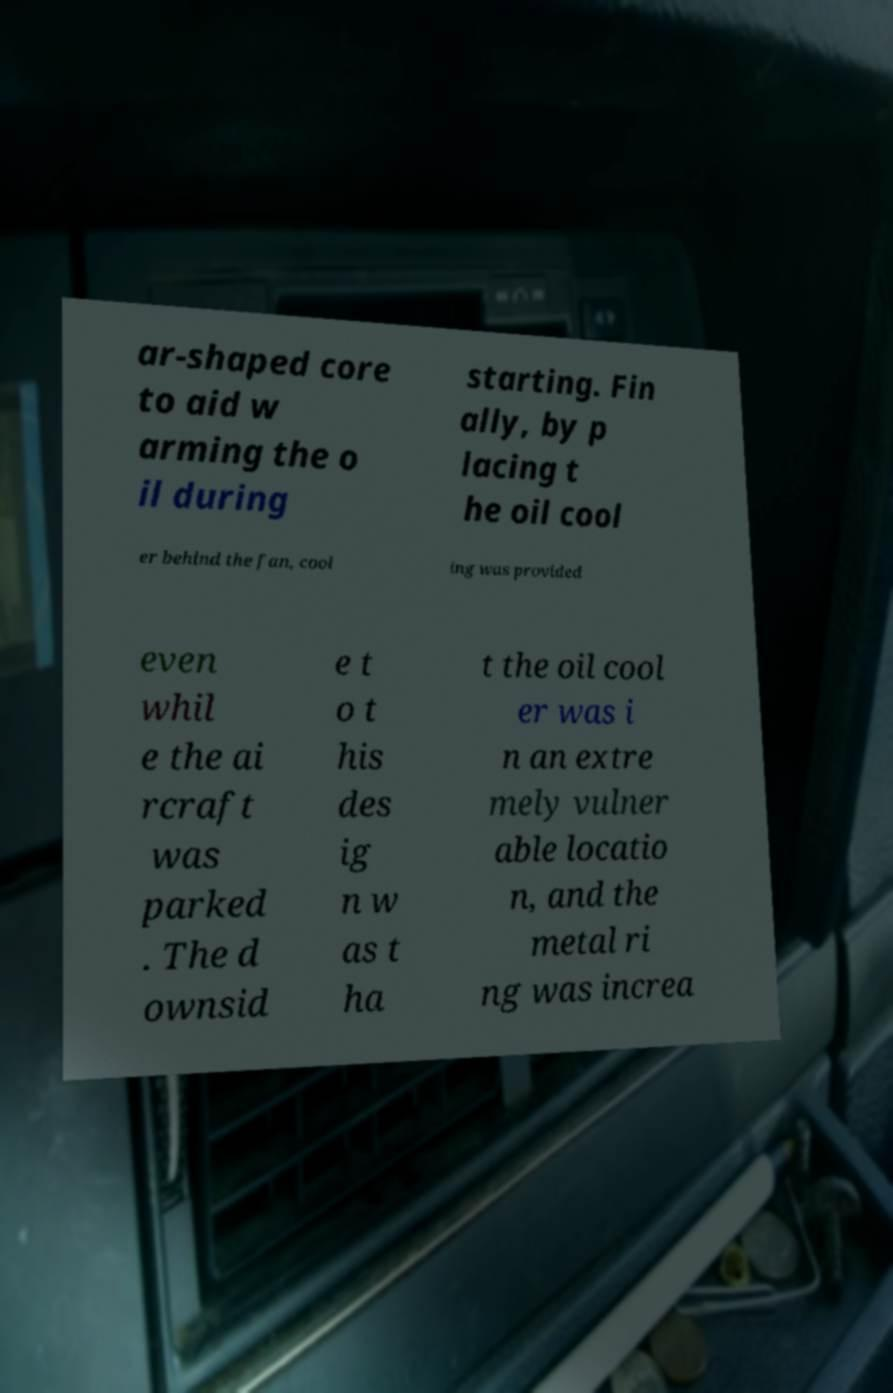I need the written content from this picture converted into text. Can you do that? ar-shaped core to aid w arming the o il during starting. Fin ally, by p lacing t he oil cool er behind the fan, cool ing was provided even whil e the ai rcraft was parked . The d ownsid e t o t his des ig n w as t ha t the oil cool er was i n an extre mely vulner able locatio n, and the metal ri ng was increa 